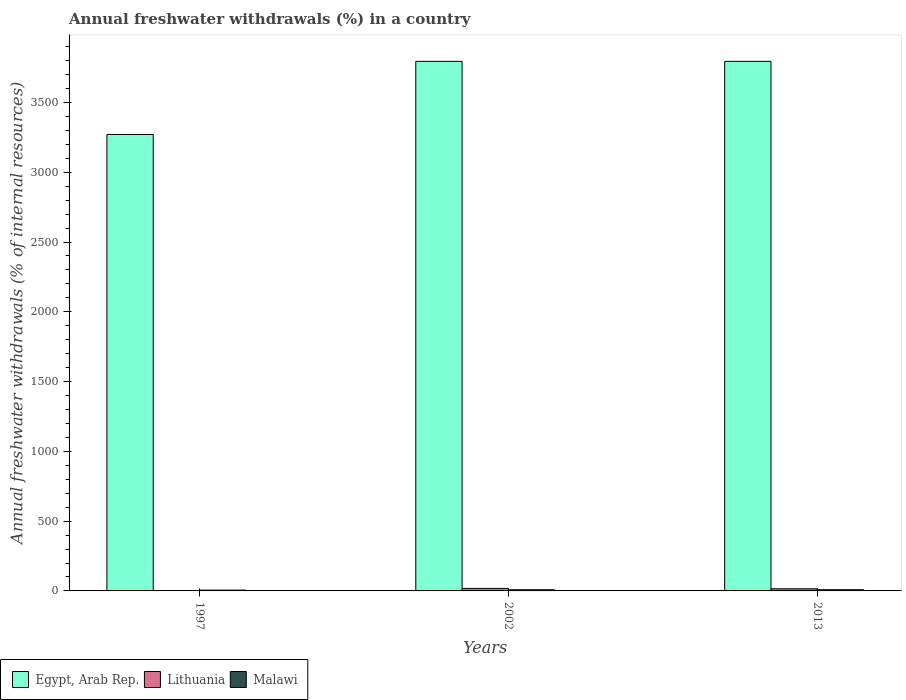How many different coloured bars are there?
Provide a short and direct response. 3. How many groups of bars are there?
Provide a short and direct response. 3. How many bars are there on the 1st tick from the right?
Provide a succinct answer. 3. In how many cases, is the number of bars for a given year not equal to the number of legend labels?
Offer a terse response. 0. What is the percentage of annual freshwater withdrawals in Egypt, Arab Rep. in 2002?
Offer a terse response. 3794.44. Across all years, what is the maximum percentage of annual freshwater withdrawals in Lithuania?
Your answer should be very brief. 17.98. Across all years, what is the minimum percentage of annual freshwater withdrawals in Malawi?
Offer a terse response. 5.8. In which year was the percentage of annual freshwater withdrawals in Malawi maximum?
Offer a very short reply. 2013. In which year was the percentage of annual freshwater withdrawals in Malawi minimum?
Your response must be concise. 1997. What is the total percentage of annual freshwater withdrawals in Egypt, Arab Rep. in the graph?
Ensure brevity in your answer.  1.09e+04. What is the difference between the percentage of annual freshwater withdrawals in Lithuania in 1997 and that in 2013?
Your answer should be very brief. -13.66. What is the difference between the percentage of annual freshwater withdrawals in Lithuania in 1997 and the percentage of annual freshwater withdrawals in Malawi in 2013?
Provide a succinct answer. -6.78. What is the average percentage of annual freshwater withdrawals in Egypt, Arab Rep. per year?
Provide a short and direct response. 3619.81. In the year 2002, what is the difference between the percentage of annual freshwater withdrawals in Egypt, Arab Rep. and percentage of annual freshwater withdrawals in Malawi?
Provide a succinct answer. 3786.24. What is the ratio of the percentage of annual freshwater withdrawals in Lithuania in 1997 to that in 2002?
Provide a succinct answer. 0.09. Is the percentage of annual freshwater withdrawals in Egypt, Arab Rep. in 1997 less than that in 2013?
Keep it short and to the point. Yes. Is the difference between the percentage of annual freshwater withdrawals in Egypt, Arab Rep. in 2002 and 2013 greater than the difference between the percentage of annual freshwater withdrawals in Malawi in 2002 and 2013?
Keep it short and to the point. Yes. What is the difference between the highest and the second highest percentage of annual freshwater withdrawals in Egypt, Arab Rep.?
Ensure brevity in your answer.  0. What is the difference between the highest and the lowest percentage of annual freshwater withdrawals in Lithuania?
Your answer should be compact. 16.36. Is the sum of the percentage of annual freshwater withdrawals in Lithuania in 1997 and 2013 greater than the maximum percentage of annual freshwater withdrawals in Malawi across all years?
Your answer should be compact. Yes. What does the 1st bar from the left in 2002 represents?
Ensure brevity in your answer.  Egypt, Arab Rep. What does the 2nd bar from the right in 2002 represents?
Give a very brief answer. Lithuania. Are all the bars in the graph horizontal?
Provide a short and direct response. No. How many years are there in the graph?
Your response must be concise. 3. Does the graph contain any zero values?
Make the answer very short. No. Where does the legend appear in the graph?
Make the answer very short. Bottom left. What is the title of the graph?
Ensure brevity in your answer.  Annual freshwater withdrawals (%) in a country. What is the label or title of the Y-axis?
Your answer should be very brief. Annual freshwater withdrawals (% of internal resources). What is the Annual freshwater withdrawals (% of internal resources) of Egypt, Arab Rep. in 1997?
Offer a terse response. 3270.56. What is the Annual freshwater withdrawals (% of internal resources) in Lithuania in 1997?
Make the answer very short. 1.63. What is the Annual freshwater withdrawals (% of internal resources) of Malawi in 1997?
Ensure brevity in your answer.  5.8. What is the Annual freshwater withdrawals (% of internal resources) in Egypt, Arab Rep. in 2002?
Give a very brief answer. 3794.44. What is the Annual freshwater withdrawals (% of internal resources) in Lithuania in 2002?
Your answer should be compact. 17.98. What is the Annual freshwater withdrawals (% of internal resources) in Malawi in 2002?
Ensure brevity in your answer.  8.21. What is the Annual freshwater withdrawals (% of internal resources) of Egypt, Arab Rep. in 2013?
Offer a terse response. 3794.44. What is the Annual freshwater withdrawals (% of internal resources) in Lithuania in 2013?
Offer a terse response. 15.28. What is the Annual freshwater withdrawals (% of internal resources) in Malawi in 2013?
Offer a very short reply. 8.41. Across all years, what is the maximum Annual freshwater withdrawals (% of internal resources) of Egypt, Arab Rep.?
Provide a succinct answer. 3794.44. Across all years, what is the maximum Annual freshwater withdrawals (% of internal resources) of Lithuania?
Your answer should be compact. 17.98. Across all years, what is the maximum Annual freshwater withdrawals (% of internal resources) of Malawi?
Keep it short and to the point. 8.41. Across all years, what is the minimum Annual freshwater withdrawals (% of internal resources) of Egypt, Arab Rep.?
Your answer should be very brief. 3270.56. Across all years, what is the minimum Annual freshwater withdrawals (% of internal resources) in Lithuania?
Keep it short and to the point. 1.63. Across all years, what is the minimum Annual freshwater withdrawals (% of internal resources) of Malawi?
Offer a terse response. 5.8. What is the total Annual freshwater withdrawals (% of internal resources) of Egypt, Arab Rep. in the graph?
Offer a terse response. 1.09e+04. What is the total Annual freshwater withdrawals (% of internal resources) of Lithuania in the graph?
Your response must be concise. 34.89. What is the total Annual freshwater withdrawals (% of internal resources) of Malawi in the graph?
Provide a short and direct response. 22.42. What is the difference between the Annual freshwater withdrawals (% of internal resources) of Egypt, Arab Rep. in 1997 and that in 2002?
Your response must be concise. -523.89. What is the difference between the Annual freshwater withdrawals (% of internal resources) in Lithuania in 1997 and that in 2002?
Make the answer very short. -16.36. What is the difference between the Annual freshwater withdrawals (% of internal resources) of Malawi in 1997 and that in 2002?
Your answer should be very brief. -2.41. What is the difference between the Annual freshwater withdrawals (% of internal resources) in Egypt, Arab Rep. in 1997 and that in 2013?
Offer a very short reply. -523.89. What is the difference between the Annual freshwater withdrawals (% of internal resources) in Lithuania in 1997 and that in 2013?
Provide a short and direct response. -13.66. What is the difference between the Annual freshwater withdrawals (% of internal resources) in Malawi in 1997 and that in 2013?
Provide a succinct answer. -2.61. What is the difference between the Annual freshwater withdrawals (% of internal resources) in Lithuania in 2002 and that in 2013?
Your answer should be compact. 2.7. What is the difference between the Annual freshwater withdrawals (% of internal resources) in Malawi in 2002 and that in 2013?
Ensure brevity in your answer.  -0.2. What is the difference between the Annual freshwater withdrawals (% of internal resources) of Egypt, Arab Rep. in 1997 and the Annual freshwater withdrawals (% of internal resources) of Lithuania in 2002?
Offer a terse response. 3252.57. What is the difference between the Annual freshwater withdrawals (% of internal resources) in Egypt, Arab Rep. in 1997 and the Annual freshwater withdrawals (% of internal resources) in Malawi in 2002?
Ensure brevity in your answer.  3262.35. What is the difference between the Annual freshwater withdrawals (% of internal resources) in Lithuania in 1997 and the Annual freshwater withdrawals (% of internal resources) in Malawi in 2002?
Make the answer very short. -6.58. What is the difference between the Annual freshwater withdrawals (% of internal resources) of Egypt, Arab Rep. in 1997 and the Annual freshwater withdrawals (% of internal resources) of Lithuania in 2013?
Your answer should be very brief. 3255.27. What is the difference between the Annual freshwater withdrawals (% of internal resources) in Egypt, Arab Rep. in 1997 and the Annual freshwater withdrawals (% of internal resources) in Malawi in 2013?
Keep it short and to the point. 3262.15. What is the difference between the Annual freshwater withdrawals (% of internal resources) in Lithuania in 1997 and the Annual freshwater withdrawals (% of internal resources) in Malawi in 2013?
Your response must be concise. -6.78. What is the difference between the Annual freshwater withdrawals (% of internal resources) in Egypt, Arab Rep. in 2002 and the Annual freshwater withdrawals (% of internal resources) in Lithuania in 2013?
Provide a succinct answer. 3779.16. What is the difference between the Annual freshwater withdrawals (% of internal resources) of Egypt, Arab Rep. in 2002 and the Annual freshwater withdrawals (% of internal resources) of Malawi in 2013?
Make the answer very short. 3786.04. What is the difference between the Annual freshwater withdrawals (% of internal resources) in Lithuania in 2002 and the Annual freshwater withdrawals (% of internal resources) in Malawi in 2013?
Offer a very short reply. 9.57. What is the average Annual freshwater withdrawals (% of internal resources) in Egypt, Arab Rep. per year?
Ensure brevity in your answer.  3619.81. What is the average Annual freshwater withdrawals (% of internal resources) in Lithuania per year?
Your answer should be very brief. 11.63. What is the average Annual freshwater withdrawals (% of internal resources) in Malawi per year?
Give a very brief answer. 7.47. In the year 1997, what is the difference between the Annual freshwater withdrawals (% of internal resources) in Egypt, Arab Rep. and Annual freshwater withdrawals (% of internal resources) in Lithuania?
Provide a succinct answer. 3268.93. In the year 1997, what is the difference between the Annual freshwater withdrawals (% of internal resources) of Egypt, Arab Rep. and Annual freshwater withdrawals (% of internal resources) of Malawi?
Your response must be concise. 3264.76. In the year 1997, what is the difference between the Annual freshwater withdrawals (% of internal resources) in Lithuania and Annual freshwater withdrawals (% of internal resources) in Malawi?
Your response must be concise. -4.17. In the year 2002, what is the difference between the Annual freshwater withdrawals (% of internal resources) in Egypt, Arab Rep. and Annual freshwater withdrawals (% of internal resources) in Lithuania?
Ensure brevity in your answer.  3776.46. In the year 2002, what is the difference between the Annual freshwater withdrawals (% of internal resources) in Egypt, Arab Rep. and Annual freshwater withdrawals (% of internal resources) in Malawi?
Your response must be concise. 3786.24. In the year 2002, what is the difference between the Annual freshwater withdrawals (% of internal resources) of Lithuania and Annual freshwater withdrawals (% of internal resources) of Malawi?
Provide a short and direct response. 9.77. In the year 2013, what is the difference between the Annual freshwater withdrawals (% of internal resources) of Egypt, Arab Rep. and Annual freshwater withdrawals (% of internal resources) of Lithuania?
Ensure brevity in your answer.  3779.16. In the year 2013, what is the difference between the Annual freshwater withdrawals (% of internal resources) of Egypt, Arab Rep. and Annual freshwater withdrawals (% of internal resources) of Malawi?
Your response must be concise. 3786.04. In the year 2013, what is the difference between the Annual freshwater withdrawals (% of internal resources) of Lithuania and Annual freshwater withdrawals (% of internal resources) of Malawi?
Ensure brevity in your answer.  6.88. What is the ratio of the Annual freshwater withdrawals (% of internal resources) in Egypt, Arab Rep. in 1997 to that in 2002?
Keep it short and to the point. 0.86. What is the ratio of the Annual freshwater withdrawals (% of internal resources) of Lithuania in 1997 to that in 2002?
Offer a terse response. 0.09. What is the ratio of the Annual freshwater withdrawals (% of internal resources) in Malawi in 1997 to that in 2002?
Your answer should be compact. 0.71. What is the ratio of the Annual freshwater withdrawals (% of internal resources) of Egypt, Arab Rep. in 1997 to that in 2013?
Offer a very short reply. 0.86. What is the ratio of the Annual freshwater withdrawals (% of internal resources) of Lithuania in 1997 to that in 2013?
Ensure brevity in your answer.  0.11. What is the ratio of the Annual freshwater withdrawals (% of internal resources) of Malawi in 1997 to that in 2013?
Give a very brief answer. 0.69. What is the ratio of the Annual freshwater withdrawals (% of internal resources) in Egypt, Arab Rep. in 2002 to that in 2013?
Your answer should be very brief. 1. What is the ratio of the Annual freshwater withdrawals (% of internal resources) of Lithuania in 2002 to that in 2013?
Provide a succinct answer. 1.18. What is the ratio of the Annual freshwater withdrawals (% of internal resources) of Malawi in 2002 to that in 2013?
Provide a short and direct response. 0.98. What is the difference between the highest and the second highest Annual freshwater withdrawals (% of internal resources) of Lithuania?
Your answer should be compact. 2.7. What is the difference between the highest and the second highest Annual freshwater withdrawals (% of internal resources) in Malawi?
Your answer should be compact. 0.2. What is the difference between the highest and the lowest Annual freshwater withdrawals (% of internal resources) of Egypt, Arab Rep.?
Give a very brief answer. 523.89. What is the difference between the highest and the lowest Annual freshwater withdrawals (% of internal resources) of Lithuania?
Your response must be concise. 16.36. What is the difference between the highest and the lowest Annual freshwater withdrawals (% of internal resources) of Malawi?
Your answer should be compact. 2.61. 